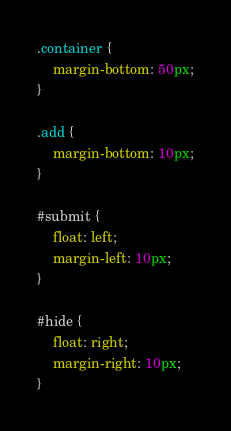Convert code to text. <code><loc_0><loc_0><loc_500><loc_500><_CSS_>.container {
    margin-bottom: 50px;
}

.add {
    margin-bottom: 10px;
}

#submit {
    float: left;
    margin-left: 10px;
}

#hide {
    float: right;
    margin-right: 10px;
}</code> 